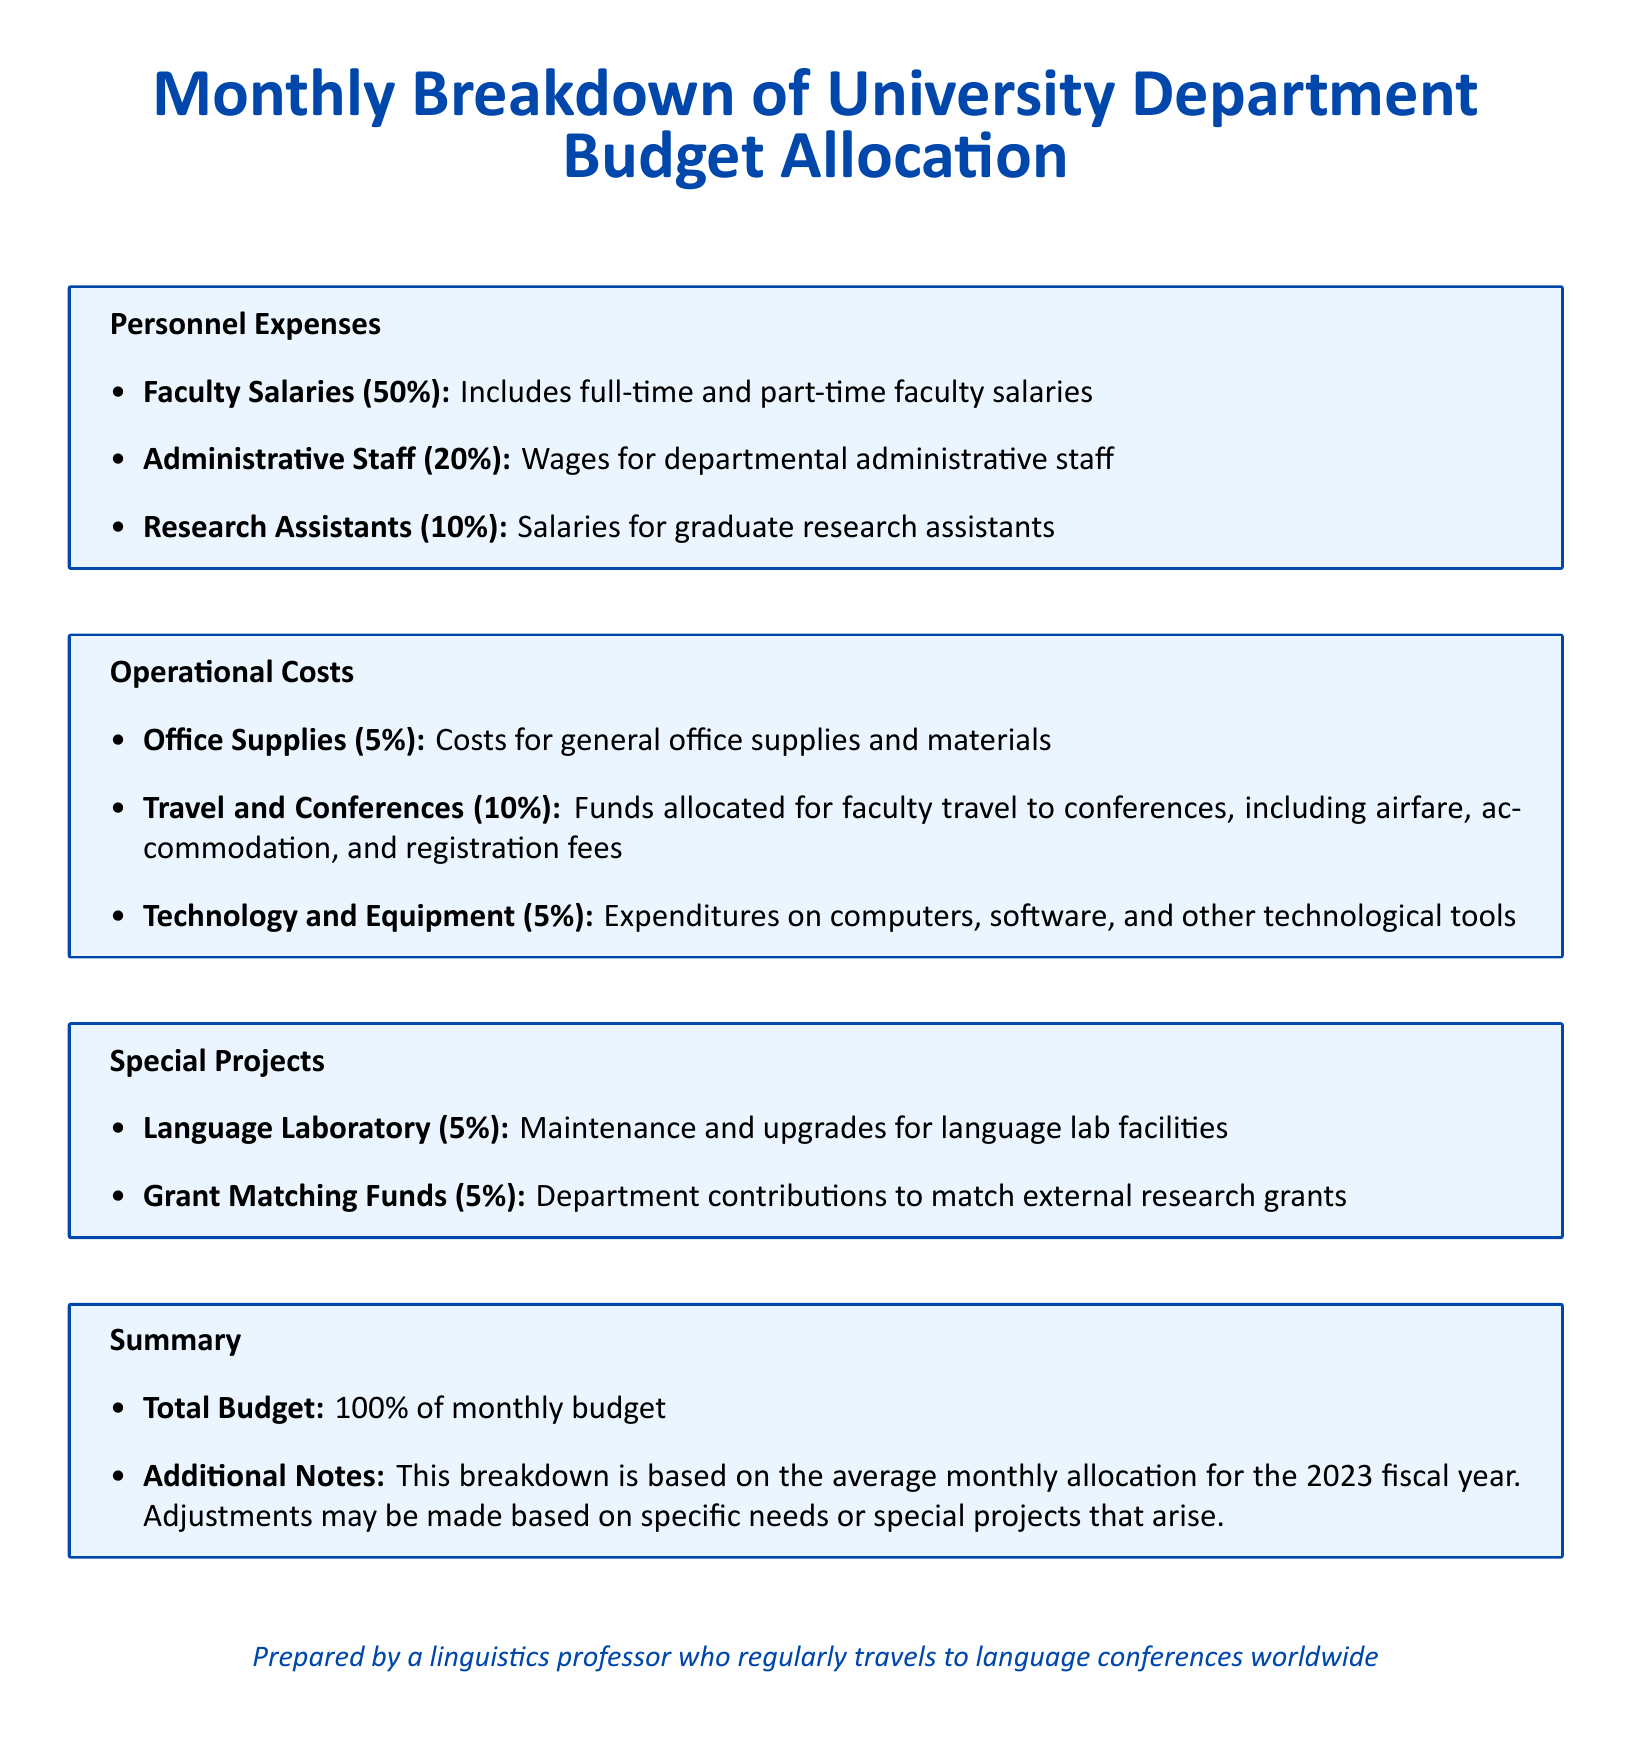What percentage of the budget is allocated to Faculty Salaries? This information can be found under Personnel Expenses, stating that Faculty Salaries represent 50% of the budget.
Answer: 50% What is the percentage allocated for Travel and Conferences? The document specifies that 10% of the budget is designated for Travel and Conferences in the Operational Costs section.
Answer: 10% How much of the budget is dedicated to Technology and Equipment? According to the Operational Costs section, Technology and Equipment account for 5% of the budget.
Answer: 5% What portion of the budget goes to Research Assistants? Under Personnel Expenses, it is stated that Research Assistants receive 10% of the total budget.
Answer: 10% What is the total percentage of Personnel Expenses in the budget allocation? Summing all the percentages related to Personnel Expenses (50% + 20% + 10%) provides the total allocation.
Answer: 80% What are the three main categories of the budget allocation? The categories are Personnel Expenses, Operational Costs, and Special Projects as outlined in the document.
Answer: Personnel Expenses, Operational Costs, Special Projects How many percent is allocated for Grant Matching Funds? Grant Matching Funds make up 5% of the budget as stated in the Special Projects section.
Answer: 5% What is the total budget percentage represented in the document? The Summary section confirms that the total budget is represented as 100% of the monthly budget allocation.
Answer: 100% What is advised regarding the budget adjustments? The document notes that adjustments may be made based on specific needs or special projects that arise, indicating the flexibility of budget allocation.
Answer: Adjustments may be made based on specific needs or special projects 